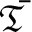<formula> <loc_0><loc_0><loc_500><loc_500>\bar { \mathfrak { T } }</formula> 